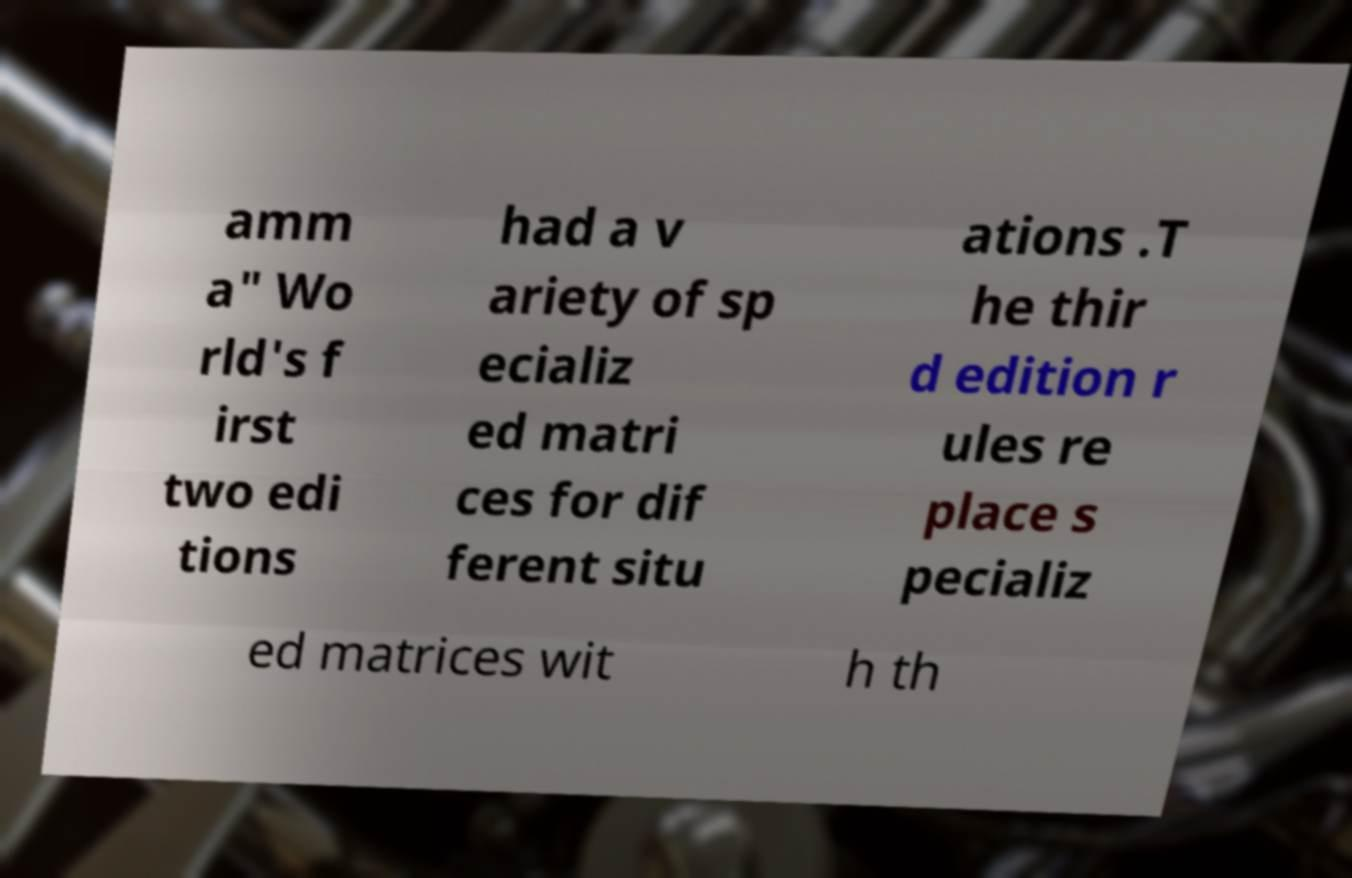There's text embedded in this image that I need extracted. Can you transcribe it verbatim? amm a" Wo rld's f irst two edi tions had a v ariety of sp ecializ ed matri ces for dif ferent situ ations .T he thir d edition r ules re place s pecializ ed matrices wit h th 